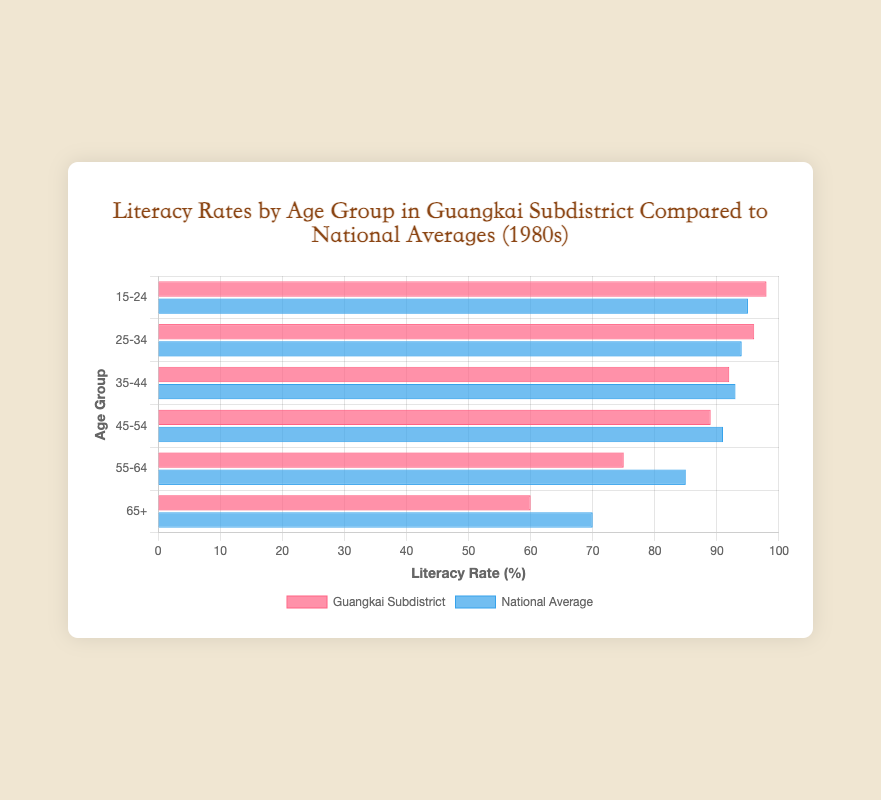Which age group in Guangkai Subdistrict has the highest literacy rate? The highest bar for Guangkai Subdistrict corresponds to the age group "15-24" with a literacy rate of 98%.
Answer: 15-24 What is the difference in literacy rates between the 55-64 age group and the 65+ age group in Guangkai Subdistrict? The literacy rate for the 55-64 age group is 75% and for the 65+ age group is 60%. The difference is 75% - 60% = 15%.
Answer: 15% How does the literacy rate of the 35-44 age group in Guangkai Subdistrict compare to the national average for the same age group? The literacy rate for the 35-44 age group in Guangkai Subdistrict is 92%, whereas the national average for the same age group is 93%. Therefore, the literacy rate in Guangkai Subdistrict is 1% lower.
Answer: 1% lower What is the average literacy rate for the 25-34 and 45-54 age groups combined in Guangkai Subdistrict? The literacy rates are 96% for the 25-34 age group and 89% for the 45-54 age group. The average is (96 + 89) / 2 = 92.5%.
Answer: 92.5% Which age group shows the largest gap between Guangkai Subdistrict and the national average? The differences are calculated as follows: 15-24: 3%, 25-34: 2%, 35-44: 1%, 45-54: 2%, 55-64: 10%, 65+: 10%. The largest gap is for the 55-64 and 65+ age groups, both with a 10% difference.
Answer: 55-64 and 65+ How many age groups have higher literacy rates in Guangkai Subdistrict compared to the national average? Comparing each age group: 15-24: higher, 25-34: higher, 35-44: lower, 45-54: lower, 55-64: lower, 65+: lower. There are 2 age groups with higher literacy rates.
Answer: 2 What is the total sum of the literacy rates for all age groups in Guangkai Subdistrict? Summing the literacy rates: 98 + 96 + 92 + 89 + 75 + 60 = 510%.
Answer: 510% Which age group's literacy rate bar is the shortest in the national average? The shortest bar for the national average corresponds to the age group "65+" with a literacy rate of 70%.
Answer: 65+ Is the literacy rate for the 45-54 age group in Guangkai Subdistrict higher or lower than the overall national average of all age groups? The national averages for all age groups add up to 528%, and the overall average is 528 / 6 = 88%. The literacy rate for the 45-54 age group in Guangkai Subdistrict is 89%, which is higher than the overall national average.
Answer: Higher 